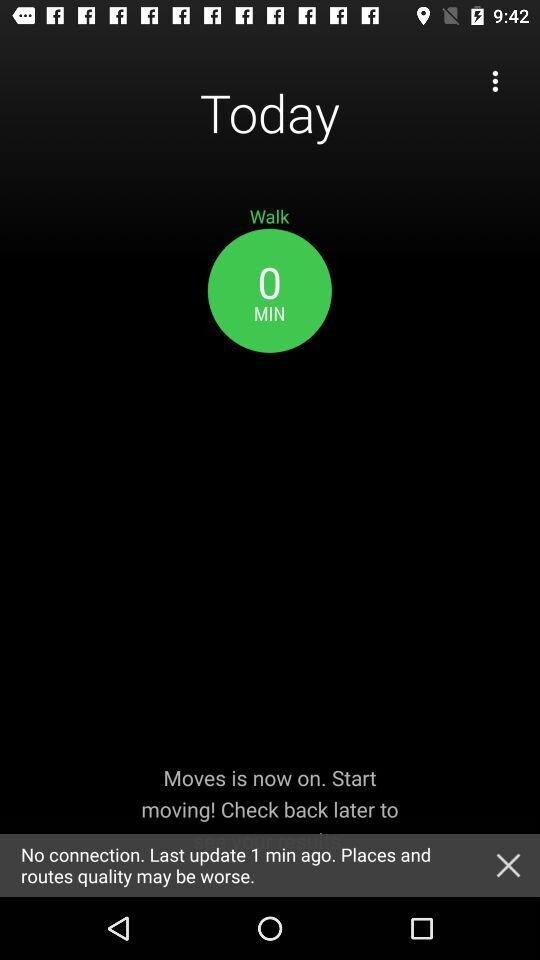How many minutes have passed since the last update?
Answer the question using a single word or phrase. 1 